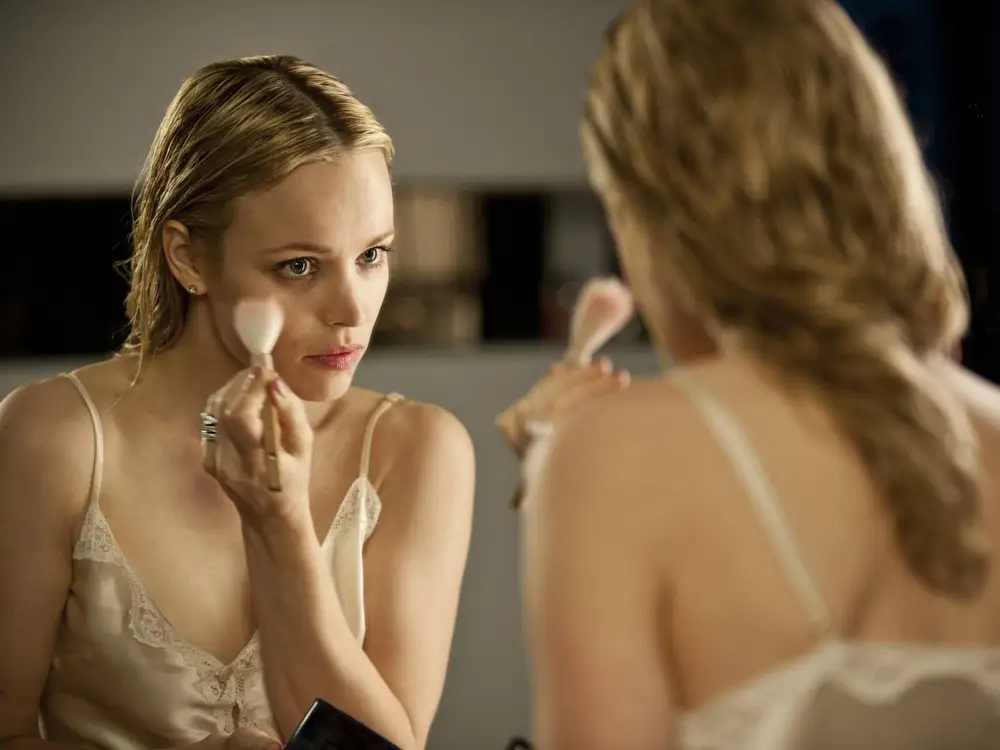Can you describe the main features of this image for me? The image captures a woman dressed in a delicate, lace-trimmed white camisole, meticulously applying makeup in front of a mirror. Her focused expression and the way she handles the makeup brush show her attention to detail. The soft lighting reflects off the mirror, highlighting her features and the texture of her lace attire, further emphasizing the intimate and serene setting of her preparation. 